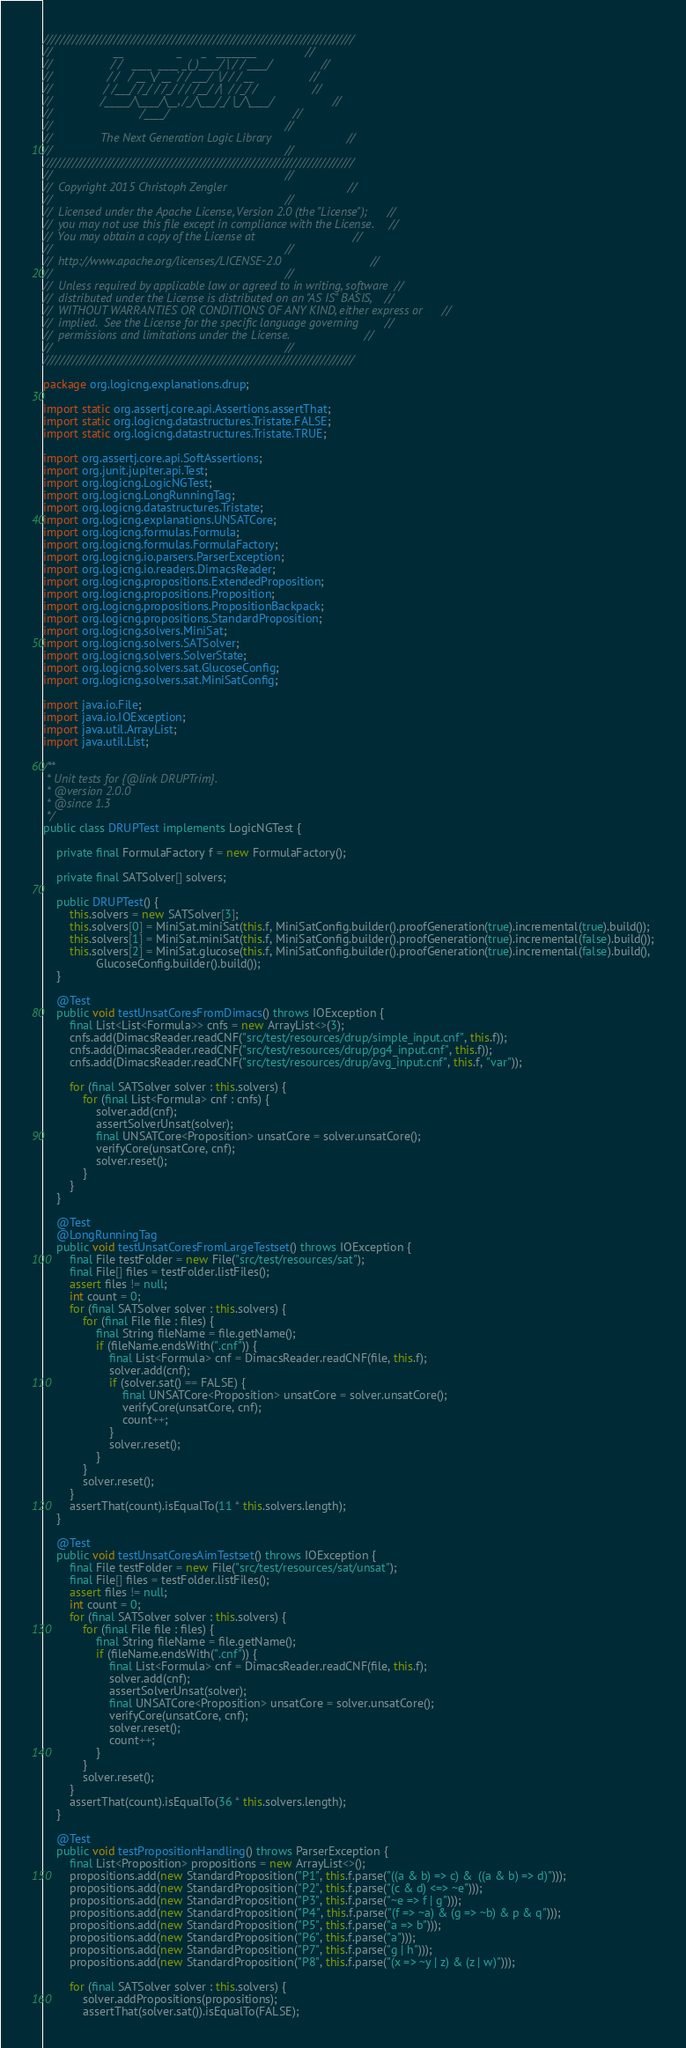Convert code to text. <code><loc_0><loc_0><loc_500><loc_500><_Java_>///////////////////////////////////////////////////////////////////////////
//                   __                _      _   ________               //
//                  / /   ____  ____ _(_)____/ | / / ____/               //
//                 / /   / __ \/ __ `/ / ___/  |/ / / __                 //
//                / /___/ /_/ / /_/ / / /__/ /|  / /_/ /                 //
//               /_____/\____/\__, /_/\___/_/ |_/\____/                  //
//                           /____/                                      //
//                                                                       //
//               The Next Generation Logic Library                       //
//                                                                       //
///////////////////////////////////////////////////////////////////////////
//                                                                       //
//  Copyright 2015 Christoph Zengler                                     //
//                                                                       //
//  Licensed under the Apache License, Version 2.0 (the "License");      //
//  you may not use this file except in compliance with the License.     //
//  You may obtain a copy of the License at                              //
//                                                                       //
//  http://www.apache.org/licenses/LICENSE-2.0                           //
//                                                                       //
//  Unless required by applicable law or agreed to in writing, software  //
//  distributed under the License is distributed on an "AS IS" BASIS,    //
//  WITHOUT WARRANTIES OR CONDITIONS OF ANY KIND, either express or      //
//  implied.  See the License for the specific language governing        //
//  permissions and limitations under the License.                       //
//                                                                       //
///////////////////////////////////////////////////////////////////////////

package org.logicng.explanations.drup;

import static org.assertj.core.api.Assertions.assertThat;
import static org.logicng.datastructures.Tristate.FALSE;
import static org.logicng.datastructures.Tristate.TRUE;

import org.assertj.core.api.SoftAssertions;
import org.junit.jupiter.api.Test;
import org.logicng.LogicNGTest;
import org.logicng.LongRunningTag;
import org.logicng.datastructures.Tristate;
import org.logicng.explanations.UNSATCore;
import org.logicng.formulas.Formula;
import org.logicng.formulas.FormulaFactory;
import org.logicng.io.parsers.ParserException;
import org.logicng.io.readers.DimacsReader;
import org.logicng.propositions.ExtendedProposition;
import org.logicng.propositions.Proposition;
import org.logicng.propositions.PropositionBackpack;
import org.logicng.propositions.StandardProposition;
import org.logicng.solvers.MiniSat;
import org.logicng.solvers.SATSolver;
import org.logicng.solvers.SolverState;
import org.logicng.solvers.sat.GlucoseConfig;
import org.logicng.solvers.sat.MiniSatConfig;

import java.io.File;
import java.io.IOException;
import java.util.ArrayList;
import java.util.List;

/**
 * Unit tests for {@link DRUPTrim}.
 * @version 2.0.0
 * @since 1.3
 */
public class DRUPTest implements LogicNGTest {

    private final FormulaFactory f = new FormulaFactory();

    private final SATSolver[] solvers;

    public DRUPTest() {
        this.solvers = new SATSolver[3];
        this.solvers[0] = MiniSat.miniSat(this.f, MiniSatConfig.builder().proofGeneration(true).incremental(true).build());
        this.solvers[1] = MiniSat.miniSat(this.f, MiniSatConfig.builder().proofGeneration(true).incremental(false).build());
        this.solvers[2] = MiniSat.glucose(this.f, MiniSatConfig.builder().proofGeneration(true).incremental(false).build(),
                GlucoseConfig.builder().build());
    }

    @Test
    public void testUnsatCoresFromDimacs() throws IOException {
        final List<List<Formula>> cnfs = new ArrayList<>(3);
        cnfs.add(DimacsReader.readCNF("src/test/resources/drup/simple_input.cnf", this.f));
        cnfs.add(DimacsReader.readCNF("src/test/resources/drup/pg4_input.cnf", this.f));
        cnfs.add(DimacsReader.readCNF("src/test/resources/drup/avg_input.cnf", this.f, "var"));

        for (final SATSolver solver : this.solvers) {
            for (final List<Formula> cnf : cnfs) {
                solver.add(cnf);
                assertSolverUnsat(solver);
                final UNSATCore<Proposition> unsatCore = solver.unsatCore();
                verifyCore(unsatCore, cnf);
                solver.reset();
            }
        }
    }

    @Test
    @LongRunningTag
    public void testUnsatCoresFromLargeTestset() throws IOException {
        final File testFolder = new File("src/test/resources/sat");
        final File[] files = testFolder.listFiles();
        assert files != null;
        int count = 0;
        for (final SATSolver solver : this.solvers) {
            for (final File file : files) {
                final String fileName = file.getName();
                if (fileName.endsWith(".cnf")) {
                    final List<Formula> cnf = DimacsReader.readCNF(file, this.f);
                    solver.add(cnf);
                    if (solver.sat() == FALSE) {
                        final UNSATCore<Proposition> unsatCore = solver.unsatCore();
                        verifyCore(unsatCore, cnf);
                        count++;
                    }
                    solver.reset();
                }
            }
            solver.reset();
        }
        assertThat(count).isEqualTo(11 * this.solvers.length);
    }

    @Test
    public void testUnsatCoresAimTestset() throws IOException {
        final File testFolder = new File("src/test/resources/sat/unsat");
        final File[] files = testFolder.listFiles();
        assert files != null;
        int count = 0;
        for (final SATSolver solver : this.solvers) {
            for (final File file : files) {
                final String fileName = file.getName();
                if (fileName.endsWith(".cnf")) {
                    final List<Formula> cnf = DimacsReader.readCNF(file, this.f);
                    solver.add(cnf);
                    assertSolverUnsat(solver);
                    final UNSATCore<Proposition> unsatCore = solver.unsatCore();
                    verifyCore(unsatCore, cnf);
                    solver.reset();
                    count++;
                }
            }
            solver.reset();
        }
        assertThat(count).isEqualTo(36 * this.solvers.length);
    }

    @Test
    public void testPropositionHandling() throws ParserException {
        final List<Proposition> propositions = new ArrayList<>();
        propositions.add(new StandardProposition("P1", this.f.parse("((a & b) => c) &  ((a & b) => d)")));
        propositions.add(new StandardProposition("P2", this.f.parse("(c & d) <=> ~e")));
        propositions.add(new StandardProposition("P3", this.f.parse("~e => f | g")));
        propositions.add(new StandardProposition("P4", this.f.parse("(f => ~a) & (g => ~b) & p & q")));
        propositions.add(new StandardProposition("P5", this.f.parse("a => b")));
        propositions.add(new StandardProposition("P6", this.f.parse("a")));
        propositions.add(new StandardProposition("P7", this.f.parse("g | h")));
        propositions.add(new StandardProposition("P8", this.f.parse("(x => ~y | z) & (z | w)")));

        for (final SATSolver solver : this.solvers) {
            solver.addPropositions(propositions);
            assertThat(solver.sat()).isEqualTo(FALSE);</code> 